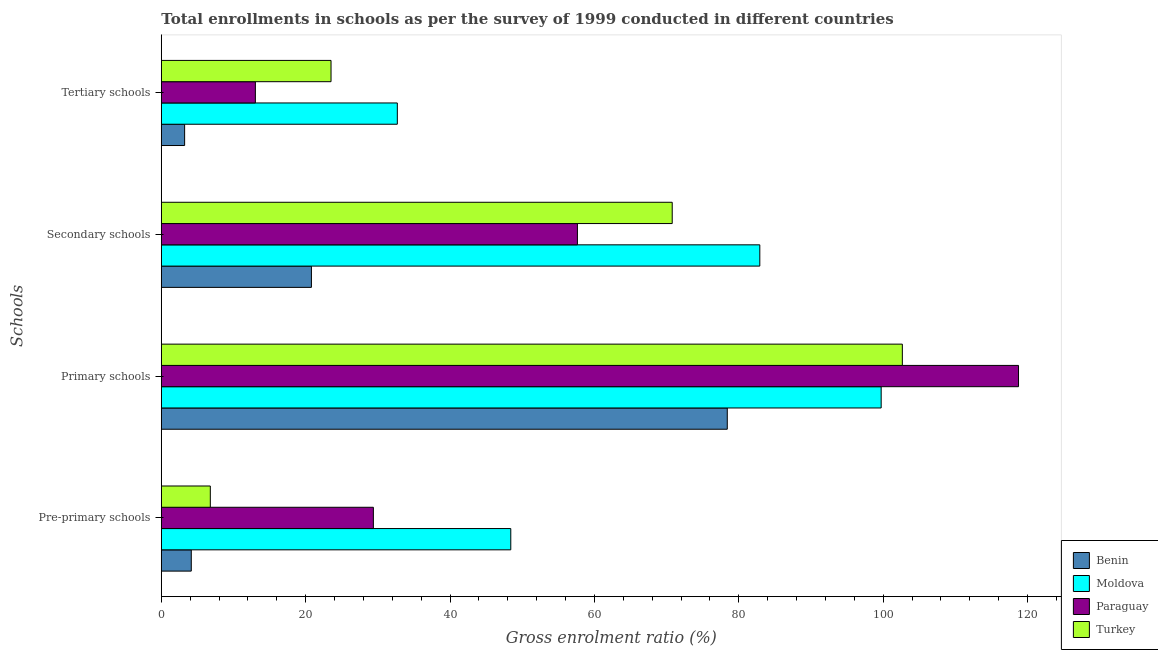How many groups of bars are there?
Your response must be concise. 4. How many bars are there on the 4th tick from the top?
Your answer should be compact. 4. What is the label of the 3rd group of bars from the top?
Provide a short and direct response. Primary schools. What is the gross enrolment ratio in primary schools in Moldova?
Ensure brevity in your answer.  99.72. Across all countries, what is the maximum gross enrolment ratio in primary schools?
Your answer should be very brief. 118.75. Across all countries, what is the minimum gross enrolment ratio in primary schools?
Give a very brief answer. 78.4. In which country was the gross enrolment ratio in pre-primary schools maximum?
Offer a very short reply. Moldova. In which country was the gross enrolment ratio in primary schools minimum?
Offer a very short reply. Benin. What is the total gross enrolment ratio in pre-primary schools in the graph?
Ensure brevity in your answer.  88.73. What is the difference between the gross enrolment ratio in pre-primary schools in Moldova and that in Paraguay?
Keep it short and to the point. 19.03. What is the difference between the gross enrolment ratio in primary schools in Moldova and the gross enrolment ratio in secondary schools in Turkey?
Ensure brevity in your answer.  28.95. What is the average gross enrolment ratio in secondary schools per country?
Offer a terse response. 58.03. What is the difference between the gross enrolment ratio in secondary schools and gross enrolment ratio in primary schools in Benin?
Keep it short and to the point. -57.61. What is the ratio of the gross enrolment ratio in pre-primary schools in Paraguay to that in Moldova?
Give a very brief answer. 0.61. Is the gross enrolment ratio in secondary schools in Benin less than that in Turkey?
Your response must be concise. Yes. Is the difference between the gross enrolment ratio in tertiary schools in Paraguay and Moldova greater than the difference between the gross enrolment ratio in secondary schools in Paraguay and Moldova?
Provide a succinct answer. Yes. What is the difference between the highest and the second highest gross enrolment ratio in secondary schools?
Give a very brief answer. 12.13. What is the difference between the highest and the lowest gross enrolment ratio in primary schools?
Ensure brevity in your answer.  40.35. Is the sum of the gross enrolment ratio in pre-primary schools in Paraguay and Moldova greater than the maximum gross enrolment ratio in primary schools across all countries?
Your response must be concise. No. Is it the case that in every country, the sum of the gross enrolment ratio in pre-primary schools and gross enrolment ratio in primary schools is greater than the sum of gross enrolment ratio in secondary schools and gross enrolment ratio in tertiary schools?
Your answer should be compact. No. What does the 3rd bar from the top in Primary schools represents?
Your response must be concise. Moldova. What does the 2nd bar from the bottom in Primary schools represents?
Ensure brevity in your answer.  Moldova. Is it the case that in every country, the sum of the gross enrolment ratio in pre-primary schools and gross enrolment ratio in primary schools is greater than the gross enrolment ratio in secondary schools?
Provide a succinct answer. Yes. Are all the bars in the graph horizontal?
Ensure brevity in your answer.  Yes. How many countries are there in the graph?
Offer a very short reply. 4. Does the graph contain any zero values?
Give a very brief answer. No. Does the graph contain grids?
Your answer should be compact. No. What is the title of the graph?
Provide a short and direct response. Total enrollments in schools as per the survey of 1999 conducted in different countries. Does "Nepal" appear as one of the legend labels in the graph?
Your response must be concise. No. What is the label or title of the Y-axis?
Keep it short and to the point. Schools. What is the Gross enrolment ratio (%) in Benin in Pre-primary schools?
Your answer should be very brief. 4.15. What is the Gross enrolment ratio (%) of Moldova in Pre-primary schools?
Offer a very short reply. 48.41. What is the Gross enrolment ratio (%) of Paraguay in Pre-primary schools?
Offer a very short reply. 29.38. What is the Gross enrolment ratio (%) of Turkey in Pre-primary schools?
Provide a short and direct response. 6.79. What is the Gross enrolment ratio (%) in Benin in Primary schools?
Make the answer very short. 78.4. What is the Gross enrolment ratio (%) of Moldova in Primary schools?
Give a very brief answer. 99.72. What is the Gross enrolment ratio (%) in Paraguay in Primary schools?
Offer a very short reply. 118.75. What is the Gross enrolment ratio (%) in Turkey in Primary schools?
Your answer should be very brief. 102.65. What is the Gross enrolment ratio (%) of Benin in Secondary schools?
Make the answer very short. 20.79. What is the Gross enrolment ratio (%) of Moldova in Secondary schools?
Your answer should be very brief. 82.91. What is the Gross enrolment ratio (%) of Paraguay in Secondary schools?
Make the answer very short. 57.64. What is the Gross enrolment ratio (%) of Turkey in Secondary schools?
Give a very brief answer. 70.78. What is the Gross enrolment ratio (%) of Benin in Tertiary schools?
Ensure brevity in your answer.  3.23. What is the Gross enrolment ratio (%) of Moldova in Tertiary schools?
Your answer should be compact. 32.69. What is the Gross enrolment ratio (%) in Paraguay in Tertiary schools?
Provide a succinct answer. 13.03. What is the Gross enrolment ratio (%) of Turkey in Tertiary schools?
Your response must be concise. 23.51. Across all Schools, what is the maximum Gross enrolment ratio (%) of Benin?
Your answer should be compact. 78.4. Across all Schools, what is the maximum Gross enrolment ratio (%) of Moldova?
Provide a short and direct response. 99.72. Across all Schools, what is the maximum Gross enrolment ratio (%) of Paraguay?
Your answer should be compact. 118.75. Across all Schools, what is the maximum Gross enrolment ratio (%) of Turkey?
Provide a short and direct response. 102.65. Across all Schools, what is the minimum Gross enrolment ratio (%) in Benin?
Provide a short and direct response. 3.23. Across all Schools, what is the minimum Gross enrolment ratio (%) of Moldova?
Ensure brevity in your answer.  32.69. Across all Schools, what is the minimum Gross enrolment ratio (%) in Paraguay?
Provide a succinct answer. 13.03. Across all Schools, what is the minimum Gross enrolment ratio (%) of Turkey?
Ensure brevity in your answer.  6.79. What is the total Gross enrolment ratio (%) of Benin in the graph?
Ensure brevity in your answer.  106.58. What is the total Gross enrolment ratio (%) in Moldova in the graph?
Your answer should be compact. 263.74. What is the total Gross enrolment ratio (%) of Paraguay in the graph?
Provide a succinct answer. 218.8. What is the total Gross enrolment ratio (%) of Turkey in the graph?
Your response must be concise. 203.73. What is the difference between the Gross enrolment ratio (%) in Benin in Pre-primary schools and that in Primary schools?
Ensure brevity in your answer.  -74.25. What is the difference between the Gross enrolment ratio (%) in Moldova in Pre-primary schools and that in Primary schools?
Offer a very short reply. -51.31. What is the difference between the Gross enrolment ratio (%) in Paraguay in Pre-primary schools and that in Primary schools?
Make the answer very short. -89.37. What is the difference between the Gross enrolment ratio (%) of Turkey in Pre-primary schools and that in Primary schools?
Provide a short and direct response. -95.87. What is the difference between the Gross enrolment ratio (%) in Benin in Pre-primary schools and that in Secondary schools?
Offer a terse response. -16.64. What is the difference between the Gross enrolment ratio (%) in Moldova in Pre-primary schools and that in Secondary schools?
Give a very brief answer. -34.5. What is the difference between the Gross enrolment ratio (%) of Paraguay in Pre-primary schools and that in Secondary schools?
Your answer should be very brief. -28.27. What is the difference between the Gross enrolment ratio (%) of Turkey in Pre-primary schools and that in Secondary schools?
Give a very brief answer. -63.99. What is the difference between the Gross enrolment ratio (%) of Benin in Pre-primary schools and that in Tertiary schools?
Provide a succinct answer. 0.92. What is the difference between the Gross enrolment ratio (%) of Moldova in Pre-primary schools and that in Tertiary schools?
Keep it short and to the point. 15.72. What is the difference between the Gross enrolment ratio (%) in Paraguay in Pre-primary schools and that in Tertiary schools?
Provide a succinct answer. 16.35. What is the difference between the Gross enrolment ratio (%) of Turkey in Pre-primary schools and that in Tertiary schools?
Your response must be concise. -16.72. What is the difference between the Gross enrolment ratio (%) in Benin in Primary schools and that in Secondary schools?
Your answer should be compact. 57.61. What is the difference between the Gross enrolment ratio (%) of Moldova in Primary schools and that in Secondary schools?
Make the answer very short. 16.81. What is the difference between the Gross enrolment ratio (%) in Paraguay in Primary schools and that in Secondary schools?
Offer a terse response. 61.11. What is the difference between the Gross enrolment ratio (%) in Turkey in Primary schools and that in Secondary schools?
Keep it short and to the point. 31.88. What is the difference between the Gross enrolment ratio (%) in Benin in Primary schools and that in Tertiary schools?
Provide a short and direct response. 75.17. What is the difference between the Gross enrolment ratio (%) in Moldova in Primary schools and that in Tertiary schools?
Provide a short and direct response. 67.03. What is the difference between the Gross enrolment ratio (%) of Paraguay in Primary schools and that in Tertiary schools?
Make the answer very short. 105.72. What is the difference between the Gross enrolment ratio (%) of Turkey in Primary schools and that in Tertiary schools?
Your answer should be compact. 79.14. What is the difference between the Gross enrolment ratio (%) in Benin in Secondary schools and that in Tertiary schools?
Your answer should be compact. 17.56. What is the difference between the Gross enrolment ratio (%) in Moldova in Secondary schools and that in Tertiary schools?
Ensure brevity in your answer.  50.22. What is the difference between the Gross enrolment ratio (%) of Paraguay in Secondary schools and that in Tertiary schools?
Your response must be concise. 44.61. What is the difference between the Gross enrolment ratio (%) in Turkey in Secondary schools and that in Tertiary schools?
Give a very brief answer. 47.26. What is the difference between the Gross enrolment ratio (%) in Benin in Pre-primary schools and the Gross enrolment ratio (%) in Moldova in Primary schools?
Provide a succinct answer. -95.57. What is the difference between the Gross enrolment ratio (%) of Benin in Pre-primary schools and the Gross enrolment ratio (%) of Paraguay in Primary schools?
Keep it short and to the point. -114.6. What is the difference between the Gross enrolment ratio (%) of Benin in Pre-primary schools and the Gross enrolment ratio (%) of Turkey in Primary schools?
Your answer should be compact. -98.5. What is the difference between the Gross enrolment ratio (%) in Moldova in Pre-primary schools and the Gross enrolment ratio (%) in Paraguay in Primary schools?
Offer a terse response. -70.34. What is the difference between the Gross enrolment ratio (%) of Moldova in Pre-primary schools and the Gross enrolment ratio (%) of Turkey in Primary schools?
Your answer should be compact. -54.24. What is the difference between the Gross enrolment ratio (%) of Paraguay in Pre-primary schools and the Gross enrolment ratio (%) of Turkey in Primary schools?
Your answer should be very brief. -73.28. What is the difference between the Gross enrolment ratio (%) of Benin in Pre-primary schools and the Gross enrolment ratio (%) of Moldova in Secondary schools?
Give a very brief answer. -78.76. What is the difference between the Gross enrolment ratio (%) of Benin in Pre-primary schools and the Gross enrolment ratio (%) of Paraguay in Secondary schools?
Ensure brevity in your answer.  -53.49. What is the difference between the Gross enrolment ratio (%) of Benin in Pre-primary schools and the Gross enrolment ratio (%) of Turkey in Secondary schools?
Your answer should be compact. -66.63. What is the difference between the Gross enrolment ratio (%) in Moldova in Pre-primary schools and the Gross enrolment ratio (%) in Paraguay in Secondary schools?
Offer a very short reply. -9.23. What is the difference between the Gross enrolment ratio (%) in Moldova in Pre-primary schools and the Gross enrolment ratio (%) in Turkey in Secondary schools?
Offer a terse response. -22.36. What is the difference between the Gross enrolment ratio (%) in Paraguay in Pre-primary schools and the Gross enrolment ratio (%) in Turkey in Secondary schools?
Offer a very short reply. -41.4. What is the difference between the Gross enrolment ratio (%) of Benin in Pre-primary schools and the Gross enrolment ratio (%) of Moldova in Tertiary schools?
Give a very brief answer. -28.54. What is the difference between the Gross enrolment ratio (%) of Benin in Pre-primary schools and the Gross enrolment ratio (%) of Paraguay in Tertiary schools?
Offer a very short reply. -8.88. What is the difference between the Gross enrolment ratio (%) in Benin in Pre-primary schools and the Gross enrolment ratio (%) in Turkey in Tertiary schools?
Provide a succinct answer. -19.36. What is the difference between the Gross enrolment ratio (%) of Moldova in Pre-primary schools and the Gross enrolment ratio (%) of Paraguay in Tertiary schools?
Ensure brevity in your answer.  35.38. What is the difference between the Gross enrolment ratio (%) in Moldova in Pre-primary schools and the Gross enrolment ratio (%) in Turkey in Tertiary schools?
Provide a succinct answer. 24.9. What is the difference between the Gross enrolment ratio (%) of Paraguay in Pre-primary schools and the Gross enrolment ratio (%) of Turkey in Tertiary schools?
Offer a very short reply. 5.87. What is the difference between the Gross enrolment ratio (%) in Benin in Primary schools and the Gross enrolment ratio (%) in Moldova in Secondary schools?
Your answer should be compact. -4.51. What is the difference between the Gross enrolment ratio (%) of Benin in Primary schools and the Gross enrolment ratio (%) of Paraguay in Secondary schools?
Ensure brevity in your answer.  20.76. What is the difference between the Gross enrolment ratio (%) of Benin in Primary schools and the Gross enrolment ratio (%) of Turkey in Secondary schools?
Keep it short and to the point. 7.63. What is the difference between the Gross enrolment ratio (%) of Moldova in Primary schools and the Gross enrolment ratio (%) of Paraguay in Secondary schools?
Provide a short and direct response. 42.08. What is the difference between the Gross enrolment ratio (%) in Moldova in Primary schools and the Gross enrolment ratio (%) in Turkey in Secondary schools?
Your response must be concise. 28.95. What is the difference between the Gross enrolment ratio (%) in Paraguay in Primary schools and the Gross enrolment ratio (%) in Turkey in Secondary schools?
Ensure brevity in your answer.  47.97. What is the difference between the Gross enrolment ratio (%) in Benin in Primary schools and the Gross enrolment ratio (%) in Moldova in Tertiary schools?
Give a very brief answer. 45.71. What is the difference between the Gross enrolment ratio (%) in Benin in Primary schools and the Gross enrolment ratio (%) in Paraguay in Tertiary schools?
Keep it short and to the point. 65.37. What is the difference between the Gross enrolment ratio (%) in Benin in Primary schools and the Gross enrolment ratio (%) in Turkey in Tertiary schools?
Keep it short and to the point. 54.89. What is the difference between the Gross enrolment ratio (%) in Moldova in Primary schools and the Gross enrolment ratio (%) in Paraguay in Tertiary schools?
Offer a very short reply. 86.69. What is the difference between the Gross enrolment ratio (%) in Moldova in Primary schools and the Gross enrolment ratio (%) in Turkey in Tertiary schools?
Offer a very short reply. 76.21. What is the difference between the Gross enrolment ratio (%) of Paraguay in Primary schools and the Gross enrolment ratio (%) of Turkey in Tertiary schools?
Make the answer very short. 95.24. What is the difference between the Gross enrolment ratio (%) in Benin in Secondary schools and the Gross enrolment ratio (%) in Moldova in Tertiary schools?
Provide a succinct answer. -11.9. What is the difference between the Gross enrolment ratio (%) in Benin in Secondary schools and the Gross enrolment ratio (%) in Paraguay in Tertiary schools?
Your answer should be compact. 7.76. What is the difference between the Gross enrolment ratio (%) of Benin in Secondary schools and the Gross enrolment ratio (%) of Turkey in Tertiary schools?
Offer a very short reply. -2.72. What is the difference between the Gross enrolment ratio (%) of Moldova in Secondary schools and the Gross enrolment ratio (%) of Paraguay in Tertiary schools?
Offer a terse response. 69.88. What is the difference between the Gross enrolment ratio (%) of Moldova in Secondary schools and the Gross enrolment ratio (%) of Turkey in Tertiary schools?
Provide a succinct answer. 59.4. What is the difference between the Gross enrolment ratio (%) of Paraguay in Secondary schools and the Gross enrolment ratio (%) of Turkey in Tertiary schools?
Your answer should be very brief. 34.13. What is the average Gross enrolment ratio (%) in Benin per Schools?
Your answer should be very brief. 26.64. What is the average Gross enrolment ratio (%) of Moldova per Schools?
Keep it short and to the point. 65.93. What is the average Gross enrolment ratio (%) in Paraguay per Schools?
Keep it short and to the point. 54.7. What is the average Gross enrolment ratio (%) of Turkey per Schools?
Make the answer very short. 50.93. What is the difference between the Gross enrolment ratio (%) of Benin and Gross enrolment ratio (%) of Moldova in Pre-primary schools?
Your response must be concise. -44.26. What is the difference between the Gross enrolment ratio (%) of Benin and Gross enrolment ratio (%) of Paraguay in Pre-primary schools?
Give a very brief answer. -25.23. What is the difference between the Gross enrolment ratio (%) of Benin and Gross enrolment ratio (%) of Turkey in Pre-primary schools?
Give a very brief answer. -2.64. What is the difference between the Gross enrolment ratio (%) in Moldova and Gross enrolment ratio (%) in Paraguay in Pre-primary schools?
Make the answer very short. 19.03. What is the difference between the Gross enrolment ratio (%) of Moldova and Gross enrolment ratio (%) of Turkey in Pre-primary schools?
Your answer should be compact. 41.62. What is the difference between the Gross enrolment ratio (%) in Paraguay and Gross enrolment ratio (%) in Turkey in Pre-primary schools?
Offer a very short reply. 22.59. What is the difference between the Gross enrolment ratio (%) in Benin and Gross enrolment ratio (%) in Moldova in Primary schools?
Your answer should be very brief. -21.32. What is the difference between the Gross enrolment ratio (%) of Benin and Gross enrolment ratio (%) of Paraguay in Primary schools?
Your response must be concise. -40.35. What is the difference between the Gross enrolment ratio (%) in Benin and Gross enrolment ratio (%) in Turkey in Primary schools?
Make the answer very short. -24.25. What is the difference between the Gross enrolment ratio (%) in Moldova and Gross enrolment ratio (%) in Paraguay in Primary schools?
Make the answer very short. -19.03. What is the difference between the Gross enrolment ratio (%) in Moldova and Gross enrolment ratio (%) in Turkey in Primary schools?
Your response must be concise. -2.93. What is the difference between the Gross enrolment ratio (%) in Paraguay and Gross enrolment ratio (%) in Turkey in Primary schools?
Offer a very short reply. 16.09. What is the difference between the Gross enrolment ratio (%) in Benin and Gross enrolment ratio (%) in Moldova in Secondary schools?
Your response must be concise. -62.12. What is the difference between the Gross enrolment ratio (%) in Benin and Gross enrolment ratio (%) in Paraguay in Secondary schools?
Offer a very short reply. -36.85. What is the difference between the Gross enrolment ratio (%) of Benin and Gross enrolment ratio (%) of Turkey in Secondary schools?
Keep it short and to the point. -49.98. What is the difference between the Gross enrolment ratio (%) of Moldova and Gross enrolment ratio (%) of Paraguay in Secondary schools?
Your answer should be very brief. 25.27. What is the difference between the Gross enrolment ratio (%) in Moldova and Gross enrolment ratio (%) in Turkey in Secondary schools?
Your response must be concise. 12.13. What is the difference between the Gross enrolment ratio (%) in Paraguay and Gross enrolment ratio (%) in Turkey in Secondary schools?
Offer a terse response. -13.13. What is the difference between the Gross enrolment ratio (%) of Benin and Gross enrolment ratio (%) of Moldova in Tertiary schools?
Offer a terse response. -29.47. What is the difference between the Gross enrolment ratio (%) in Benin and Gross enrolment ratio (%) in Paraguay in Tertiary schools?
Offer a terse response. -9.8. What is the difference between the Gross enrolment ratio (%) in Benin and Gross enrolment ratio (%) in Turkey in Tertiary schools?
Give a very brief answer. -20.28. What is the difference between the Gross enrolment ratio (%) of Moldova and Gross enrolment ratio (%) of Paraguay in Tertiary schools?
Your response must be concise. 19.66. What is the difference between the Gross enrolment ratio (%) in Moldova and Gross enrolment ratio (%) in Turkey in Tertiary schools?
Keep it short and to the point. 9.18. What is the difference between the Gross enrolment ratio (%) of Paraguay and Gross enrolment ratio (%) of Turkey in Tertiary schools?
Provide a succinct answer. -10.48. What is the ratio of the Gross enrolment ratio (%) of Benin in Pre-primary schools to that in Primary schools?
Offer a terse response. 0.05. What is the ratio of the Gross enrolment ratio (%) in Moldova in Pre-primary schools to that in Primary schools?
Provide a succinct answer. 0.49. What is the ratio of the Gross enrolment ratio (%) in Paraguay in Pre-primary schools to that in Primary schools?
Keep it short and to the point. 0.25. What is the ratio of the Gross enrolment ratio (%) of Turkey in Pre-primary schools to that in Primary schools?
Ensure brevity in your answer.  0.07. What is the ratio of the Gross enrolment ratio (%) of Benin in Pre-primary schools to that in Secondary schools?
Provide a short and direct response. 0.2. What is the ratio of the Gross enrolment ratio (%) of Moldova in Pre-primary schools to that in Secondary schools?
Your answer should be compact. 0.58. What is the ratio of the Gross enrolment ratio (%) in Paraguay in Pre-primary schools to that in Secondary schools?
Provide a succinct answer. 0.51. What is the ratio of the Gross enrolment ratio (%) in Turkey in Pre-primary schools to that in Secondary schools?
Provide a succinct answer. 0.1. What is the ratio of the Gross enrolment ratio (%) in Benin in Pre-primary schools to that in Tertiary schools?
Your response must be concise. 1.29. What is the ratio of the Gross enrolment ratio (%) in Moldova in Pre-primary schools to that in Tertiary schools?
Your answer should be very brief. 1.48. What is the ratio of the Gross enrolment ratio (%) in Paraguay in Pre-primary schools to that in Tertiary schools?
Your response must be concise. 2.25. What is the ratio of the Gross enrolment ratio (%) of Turkey in Pre-primary schools to that in Tertiary schools?
Make the answer very short. 0.29. What is the ratio of the Gross enrolment ratio (%) of Benin in Primary schools to that in Secondary schools?
Make the answer very short. 3.77. What is the ratio of the Gross enrolment ratio (%) in Moldova in Primary schools to that in Secondary schools?
Your answer should be compact. 1.2. What is the ratio of the Gross enrolment ratio (%) in Paraguay in Primary schools to that in Secondary schools?
Provide a succinct answer. 2.06. What is the ratio of the Gross enrolment ratio (%) of Turkey in Primary schools to that in Secondary schools?
Provide a short and direct response. 1.45. What is the ratio of the Gross enrolment ratio (%) of Benin in Primary schools to that in Tertiary schools?
Give a very brief answer. 24.28. What is the ratio of the Gross enrolment ratio (%) in Moldova in Primary schools to that in Tertiary schools?
Make the answer very short. 3.05. What is the ratio of the Gross enrolment ratio (%) of Paraguay in Primary schools to that in Tertiary schools?
Keep it short and to the point. 9.11. What is the ratio of the Gross enrolment ratio (%) of Turkey in Primary schools to that in Tertiary schools?
Give a very brief answer. 4.37. What is the ratio of the Gross enrolment ratio (%) in Benin in Secondary schools to that in Tertiary schools?
Ensure brevity in your answer.  6.44. What is the ratio of the Gross enrolment ratio (%) in Moldova in Secondary schools to that in Tertiary schools?
Offer a very short reply. 2.54. What is the ratio of the Gross enrolment ratio (%) of Paraguay in Secondary schools to that in Tertiary schools?
Ensure brevity in your answer.  4.42. What is the ratio of the Gross enrolment ratio (%) of Turkey in Secondary schools to that in Tertiary schools?
Ensure brevity in your answer.  3.01. What is the difference between the highest and the second highest Gross enrolment ratio (%) of Benin?
Provide a succinct answer. 57.61. What is the difference between the highest and the second highest Gross enrolment ratio (%) in Moldova?
Offer a terse response. 16.81. What is the difference between the highest and the second highest Gross enrolment ratio (%) of Paraguay?
Provide a succinct answer. 61.11. What is the difference between the highest and the second highest Gross enrolment ratio (%) in Turkey?
Make the answer very short. 31.88. What is the difference between the highest and the lowest Gross enrolment ratio (%) of Benin?
Give a very brief answer. 75.17. What is the difference between the highest and the lowest Gross enrolment ratio (%) in Moldova?
Give a very brief answer. 67.03. What is the difference between the highest and the lowest Gross enrolment ratio (%) of Paraguay?
Provide a succinct answer. 105.72. What is the difference between the highest and the lowest Gross enrolment ratio (%) of Turkey?
Provide a short and direct response. 95.87. 